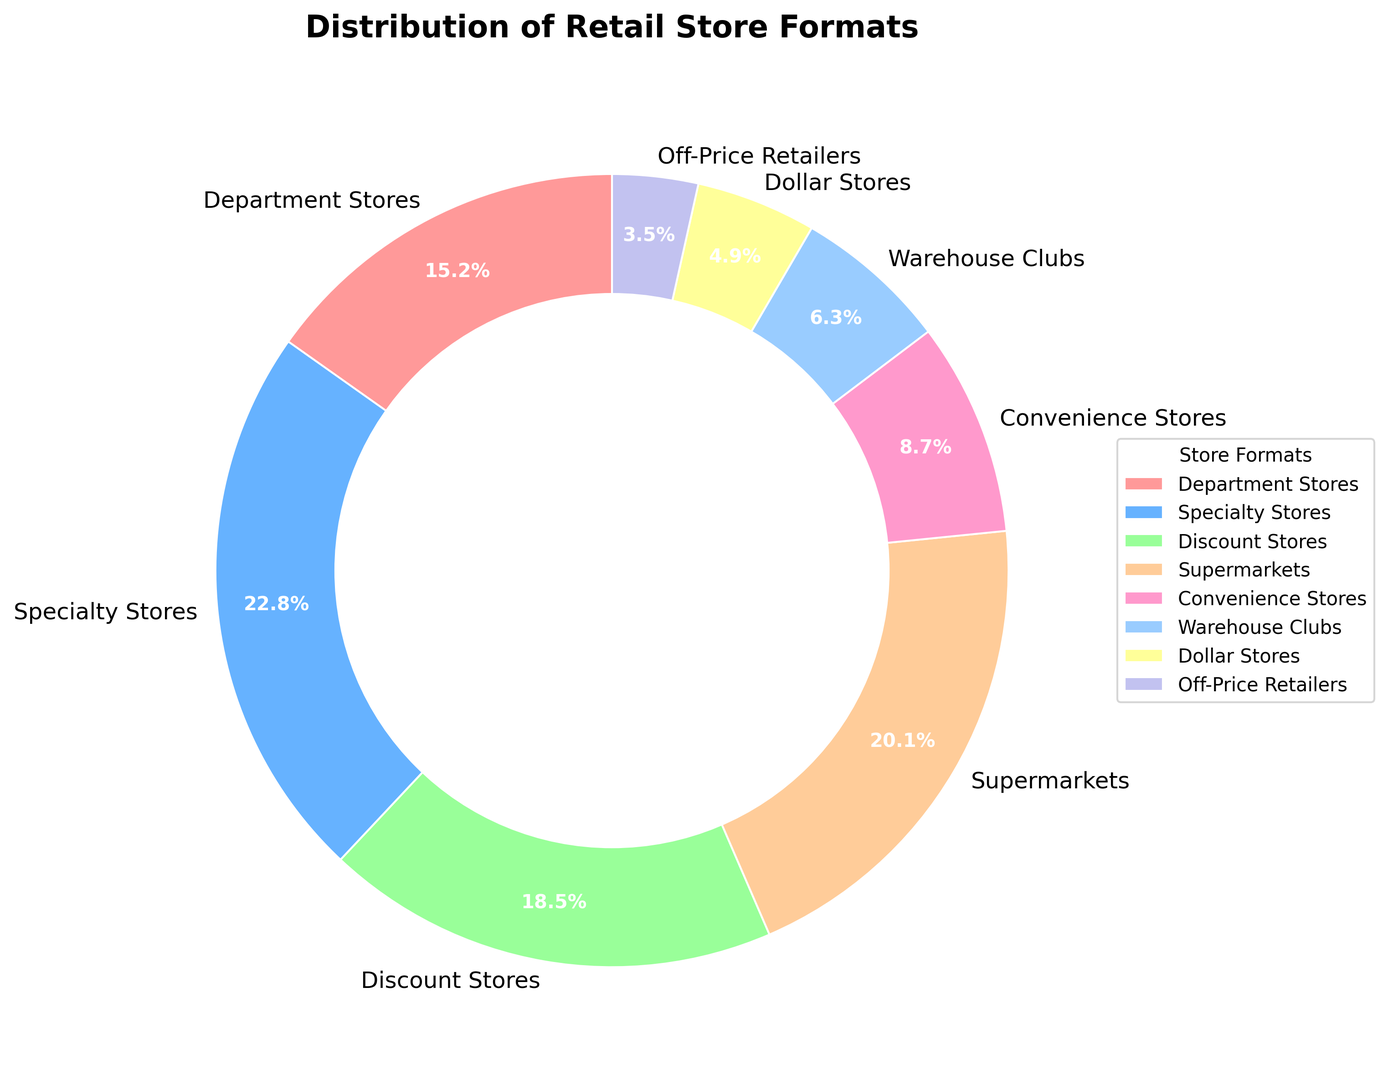What is the combined percentage of Department Stores and Specialty Stores? To find the combined percentage, sum the individual percentages of Department Stores (15.2%) and Specialty Stores (22.8%). 15.2 + 22.8 = 38.0
Answer: 38.0 What is the average percentage of Supermarkets, Convenience Stores, and Dollar Stores? Sum the percentages of Supermarkets (20.1%), Convenience Stores (8.7%), and Dollar Stores (4.9%), then divide by 3: (20.1 + 8.7 + 4.9) / 3 ≈ 11.23
Answer: 11.23 What is the difference in percentage between Discount Stores and Warehouse Clubs? Subtract the percentage of Warehouse Clubs (6.3%) from the percentage of Discount Stores (18.5%). 18.5 - 6.3 = 12.2
Answer: 12.2 What is the total percentage of store formats that have less than 10% share? Summing the percentages of Convenience Stores (8.7%), Warehouse Clubs (6.3%), Dollar Stores (4.9%), and Off-Price Retailers (3.5%): 8.7 + 6.3 + 4.9 + 3.5 = 23.4
Answer: 23.4 Which store format has the highest percentage? Identify the segment with the largest percentage. Specialty Stores have the largest percentage at 22.8%
Answer: Specialty Stores Which store format has a smaller percentage, Warehouse Clubs or Dollar Stores? Compare the percentages of Warehouse Clubs (6.3%) and Dollar Stores (4.9%). Dollar Stores have a smaller percentage than Warehouse Clubs
Answer: Dollar Stores Are there more Discount Stores or Supermarkets? Compare the percentages of Discount Stores (18.5%) and Supermarkets (20.1%). There are more Supermarkets compared to Discount Stores
Answer: Supermarkets Which segment of the pie chart is colored the brightest red? Observing the colors used in the pie chart, the segment representing Department Stores is in the brightest red
Answer: Department Stores What color represents the Specialty Stores segment? Looking at the pie chart, the segment for Specialty Stores is colored in blue
Answer: Blue Which segment is smallest in the chart, and what color is it? Identify the smallest segment in the chart, which is Off-Price Retailers at 3.5%, and note its color, in light purple
Answer: Off-Price Retailers, light purple 